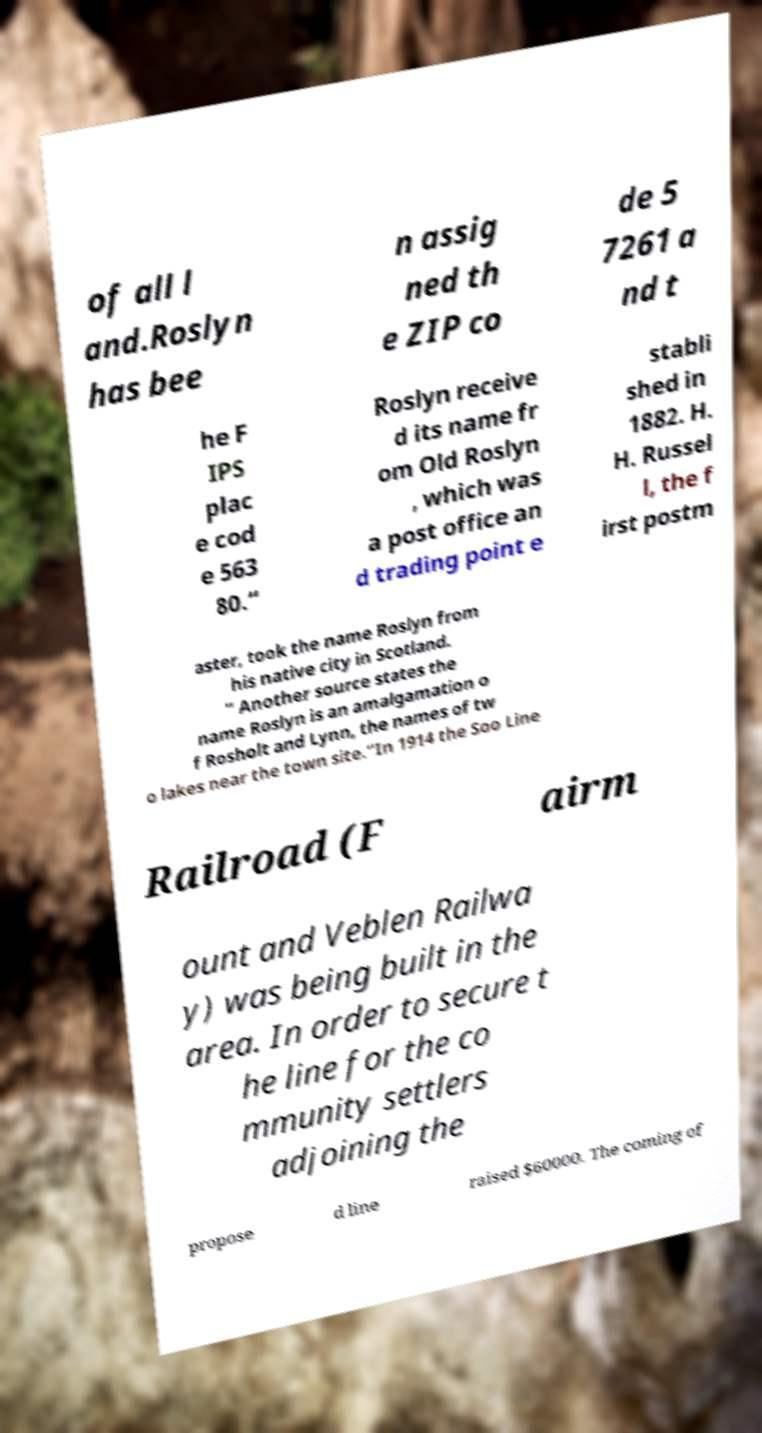There's text embedded in this image that I need extracted. Can you transcribe it verbatim? of all l and.Roslyn has bee n assig ned th e ZIP co de 5 7261 a nd t he F IPS plac e cod e 563 80.“ Roslyn receive d its name fr om Old Roslyn , which was a post office an d trading point e stabli shed in 1882. H. H. Russel l, the f irst postm aster, took the name Roslyn from his native city in Scotland. ” Another source states the name Roslyn is an amalgamation o f Rosholt and Lynn, the names of tw o lakes near the town site.“In 1914 the Soo Line Railroad (F airm ount and Veblen Railwa y) was being built in the area. In order to secure t he line for the co mmunity settlers adjoining the propose d line raised $60000. The coming of 